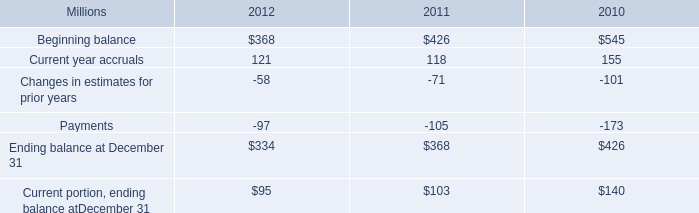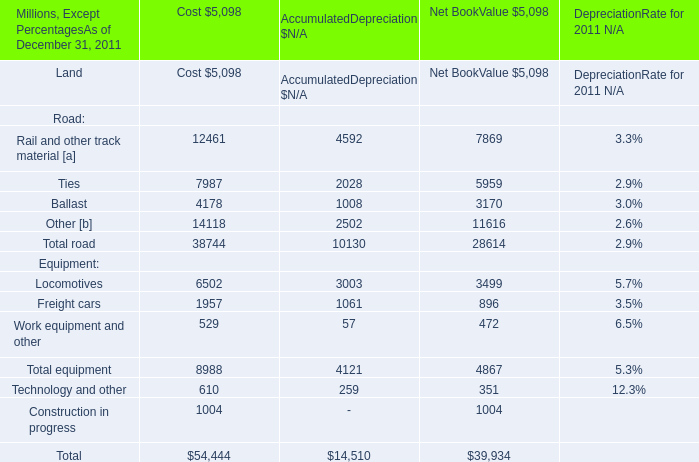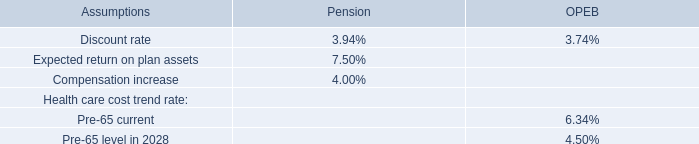Which total road exceeds 20% of total in net book value? 
Computations: (28614 * 0.2)
Answer: 5722.8. 